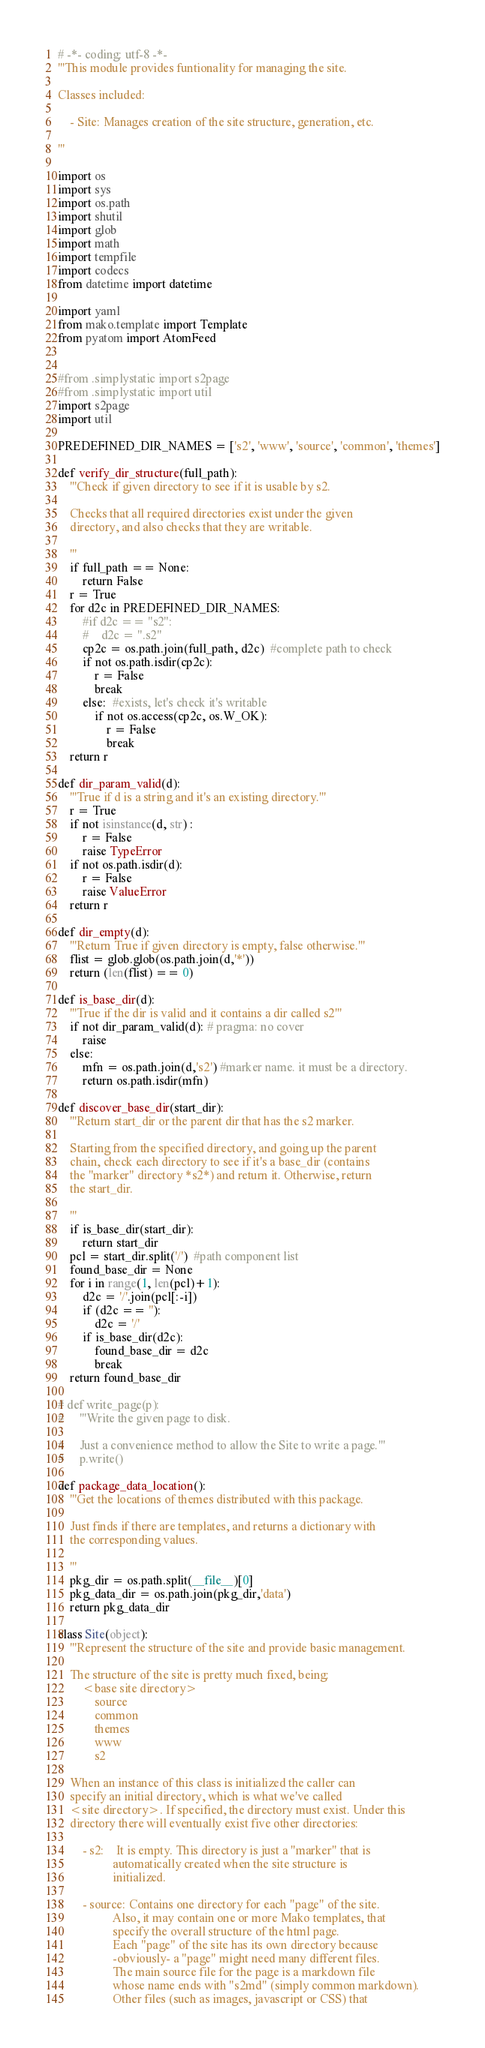<code> <loc_0><loc_0><loc_500><loc_500><_Python_># -*- coding: utf-8 -*-
'''This module provides funtionality for managing the site.

Classes included:

    - Site: Manages creation of the site structure, generation, etc.

'''

import os
import sys
import os.path
import shutil
import glob
import math
import tempfile
import codecs
from datetime import datetime

import yaml
from mako.template import Template
from pyatom import AtomFeed


#from .simplystatic import s2page
#from .simplystatic import util
import s2page
import util

PREDEFINED_DIR_NAMES = ['s2', 'www', 'source', 'common', 'themes']

def verify_dir_structure(full_path):
    '''Check if given directory to see if it is usable by s2.

    Checks that all required directories exist under the given 
    directory, and also checks that they are writable.

    '''
    if full_path == None:
        return False
    r = True
    for d2c in PREDEFINED_DIR_NAMES:
        #if d2c == "s2":
        #    d2c = ".s2"
        cp2c = os.path.join(full_path, d2c)  #complete path to check
        if not os.path.isdir(cp2c):
            r = False
            break
        else:  #exists, let's check it's writable
            if not os.access(cp2c, os.W_OK): 
                r = False
                break
    return r

def dir_param_valid(d):
    '''True if d is a string and it's an existing directory.'''
    r = True
    if not isinstance(d, str) :
        r = False
        raise TypeError
    if not os.path.isdir(d):
        r = False
        raise ValueError
    return r

def dir_empty(d):
    '''Return True if given directory is empty, false otherwise.'''
    flist = glob.glob(os.path.join(d,'*'))
    return (len(flist) == 0)

def is_base_dir(d):
    '''True if the dir is valid and it contains a dir called s2'''
    if not dir_param_valid(d): # pragma: no cover
        raise 
    else:
        mfn = os.path.join(d,'s2') #marker name. it must be a directory.
        return os.path.isdir(mfn)

def discover_base_dir(start_dir):
    '''Return start_dir or the parent dir that has the s2 marker.

    Starting from the specified directory, and going up the parent
    chain, check each directory to see if it's a base_dir (contains
    the "marker" directory *s2*) and return it. Otherwise, return
    the start_dir.

    '''
    if is_base_dir(start_dir):
        return start_dir
    pcl = start_dir.split('/')  #path component list
    found_base_dir = None
    for i in range(1, len(pcl)+1):
        d2c = '/'.join(pcl[:-i])
        if (d2c == ''):
            d2c = '/'
        if is_base_dir(d2c):
            found_base_dir = d2c
            break
    return found_base_dir

# def write_page(p):
#     '''Write the given page to disk.

#     Just a convenience method to allow the Site to write a page.'''
#     p.write()

def package_data_location():
    '''Get the locations of themes distributed with this package.

    Just finds if there are templates, and returns a dictionary with
    the corresponding values.

    '''
    pkg_dir = os.path.split(__file__)[0]
    pkg_data_dir = os.path.join(pkg_dir,'data')
    return pkg_data_dir

class Site(object):
    '''Represent the structure of the site and provide basic management.

    The structure of the site is pretty much fixed, being:
        <base site directory>
            source
            common
            themes
            www
            s2

    When an instance of this class is initialized the caller can 
    specify an initial directory, which is what we've called 
    <site directory>. If specified, the directory must exist. Under this
    directory there will eventually exist five other directories:

        - s2:    It is empty. This directory is just a "marker" that is
                  automatically created when the site structure is 
                  initialized.

        - source: Contains one directory for each "page" of the site.
                  Also, it may contain one or more Mako templates, that
                  specify the overall structure of the html page.
                  Each "page" of the site has its own directory because
                  -obviously- a "page" might need many different files.
                  The main source file for the page is a markdown file
                  whose name ends with "s2md" (simply common markdown).
                  Other files (such as images, javascript or CSS) that</code> 